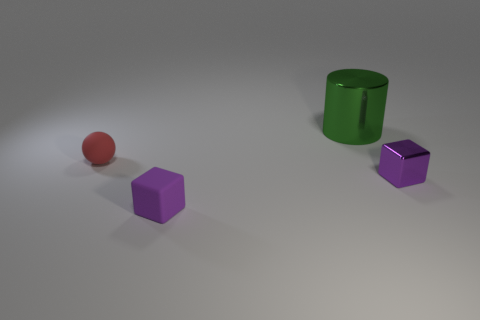Add 3 big matte balls. How many objects exist? 7 Subtract 0 gray cubes. How many objects are left? 4 Subtract all cylinders. How many objects are left? 3 Subtract all green blocks. Subtract all gray spheres. How many blocks are left? 2 Subtract all metallic things. Subtract all tiny purple shiny objects. How many objects are left? 1 Add 1 red matte balls. How many red matte balls are left? 2 Add 3 purple matte things. How many purple matte things exist? 4 